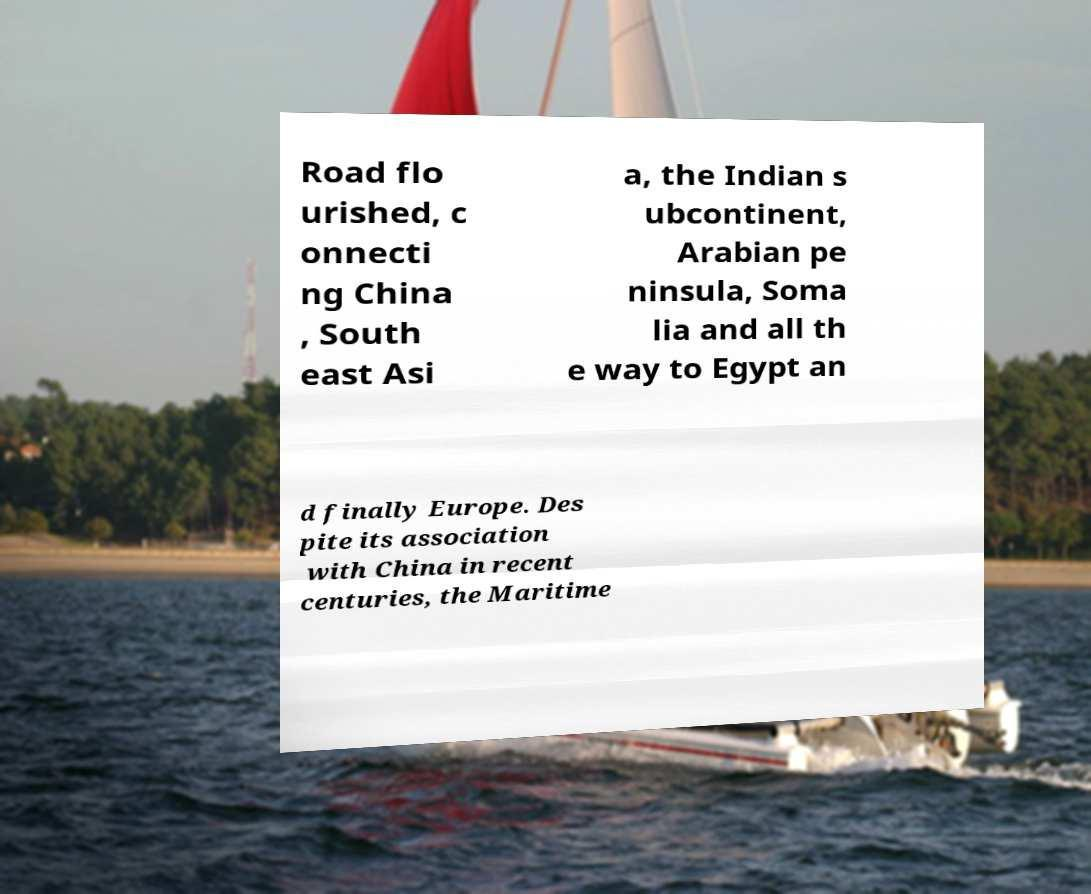Could you extract and type out the text from this image? Road flo urished, c onnecti ng China , South east Asi a, the Indian s ubcontinent, Arabian pe ninsula, Soma lia and all th e way to Egypt an d finally Europe. Des pite its association with China in recent centuries, the Maritime 